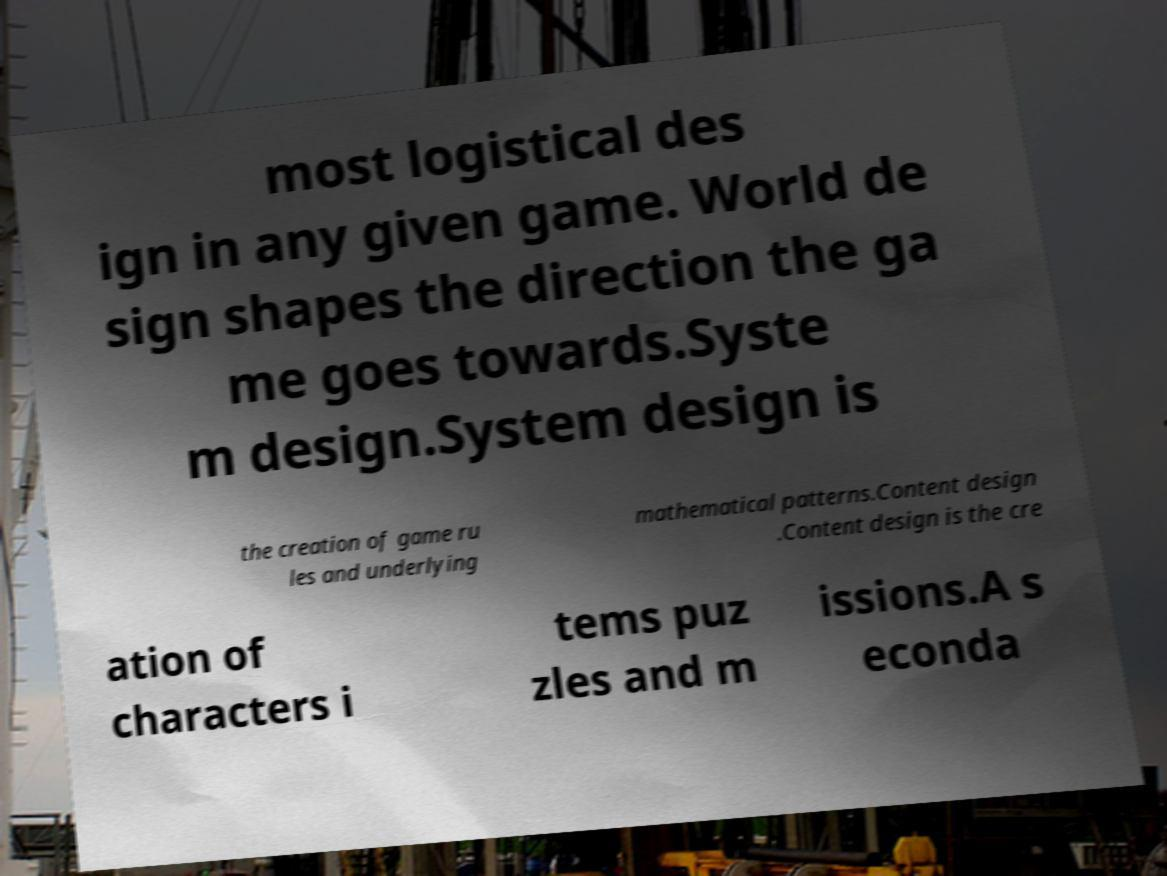Can you accurately transcribe the text from the provided image for me? most logistical des ign in any given game. World de sign shapes the direction the ga me goes towards.Syste m design.System design is the creation of game ru les and underlying mathematical patterns.Content design .Content design is the cre ation of characters i tems puz zles and m issions.A s econda 